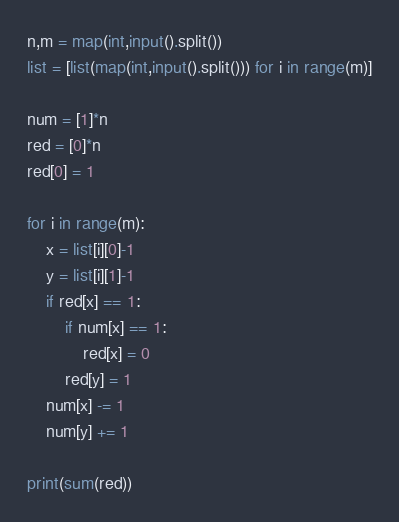Convert code to text. <code><loc_0><loc_0><loc_500><loc_500><_Python_>n,m = map(int,input().split())
list = [list(map(int,input().split())) for i in range(m)]

num = [1]*n
red = [0]*n
red[0] = 1

for i in range(m):
    x = list[i][0]-1
    y = list[i][1]-1
    if red[x] == 1:
        if num[x] == 1:
            red[x] = 0
        red[y] = 1
    num[x] -= 1
    num[y] += 1

print(sum(red))    </code> 